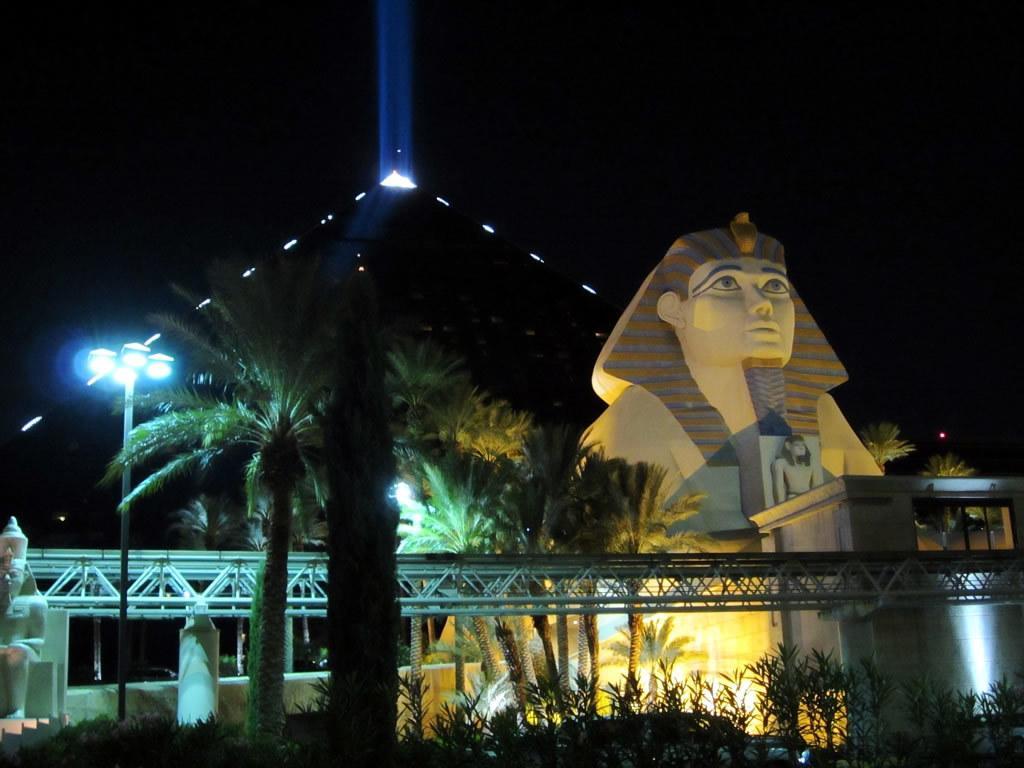Can you describe this image briefly? In this picture I can see sculptures, there are lights, there are trees, and there is dark background. 